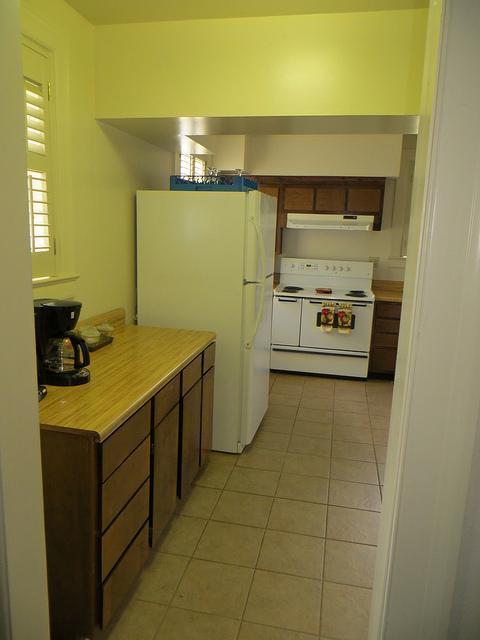How many men are holding yellow boards?
Give a very brief answer. 0. 